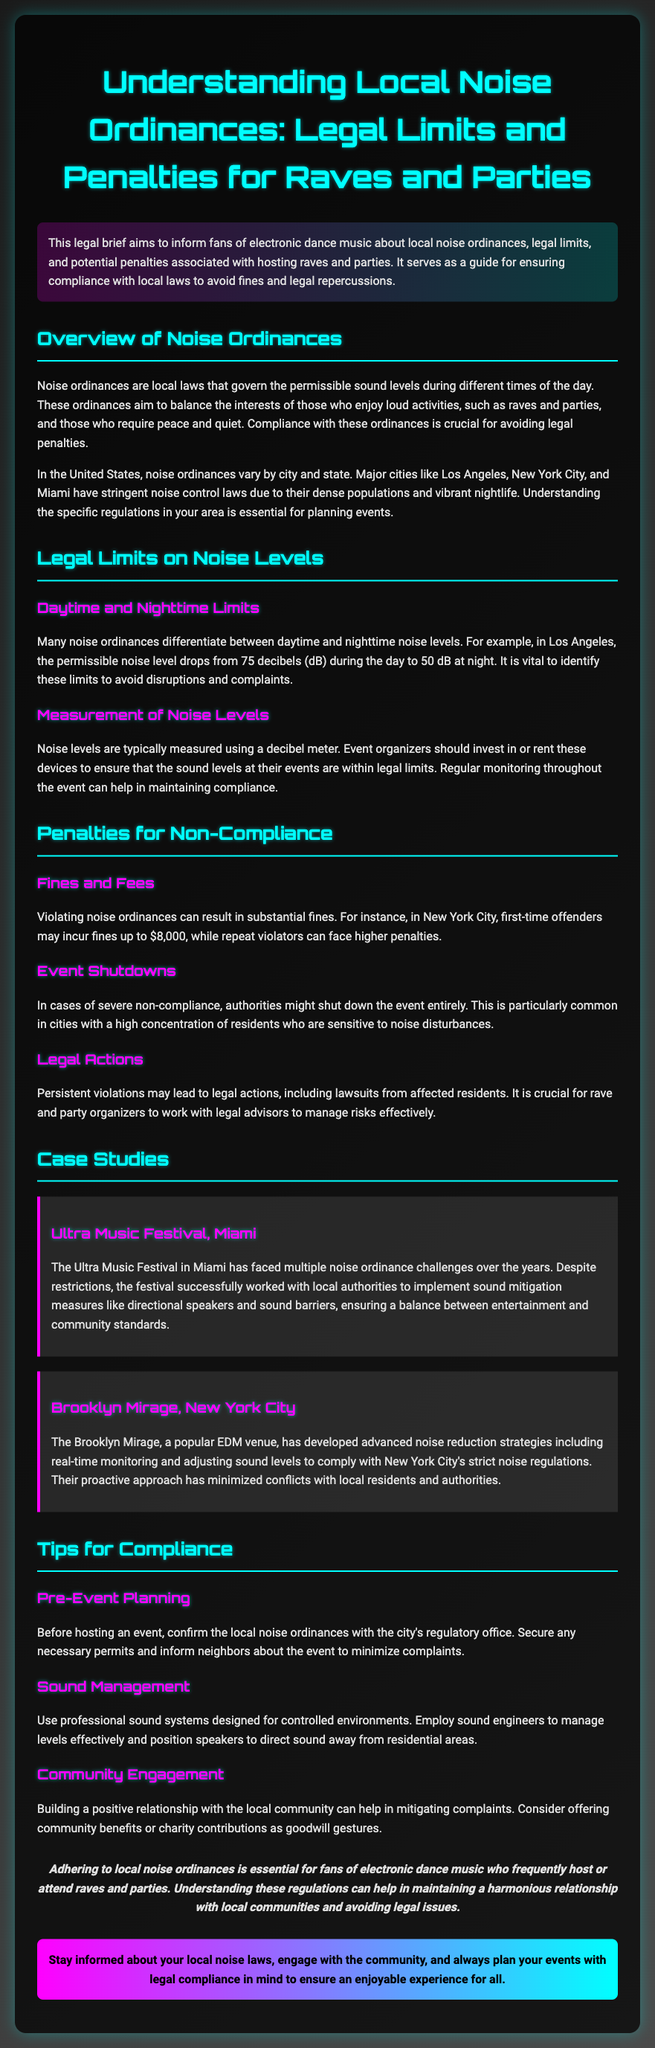what is the maximum permissible noise level in Los Angeles during the day? The document provides a specific noise limit for Los Angeles, which is 75 decibels during the day.
Answer: 75 decibels what is the maximum permissible noise level in Los Angeles at night? The legal brief mentions that the permissible noise level in Los Angeles drops to 50 decibels at night.
Answer: 50 decibels what is the fine for first-time offenders in New York City? According to the document, first-time offenders in New York City may incur fines up to $8,000.
Answer: $8,000 what are two sound management strategies recommended for event organizers? The document advises using professional sound systems and employing sound engineers as sound management strategies.
Answer: Professional sound systems and sound engineers which festival faced multiple noise ordinance challenges in Miami? The Ultra Music Festival is specifically named in the document as having faced noise ordinance challenges.
Answer: Ultra Music Festival what is a key tip for pre-event planning mentioned in the document? The legal brief highlights the importance of confirming local noise ordinances with the city’s regulatory office as a key tip for pre-event planning.
Answer: Confirm local noise ordinances what could happen in cases of severe non-compliance with noise ordinances? The brief states that authorities might shut down the event entirely in cases of severe non-compliance.
Answer: Event shutdowns what is a proactive approach taken by the Brooklyn Mirage to comply with noise regulations? The document describes the Brooklyn Mirage's use of real-time monitoring and adjusting sound levels to comply with noise regulations as a proactive approach.
Answer: Real-time monitoring what main goal do noise ordinances serve? The legal brief explains that noise ordinances aim to balance the interests of those who enjoy loud activities with those who require peace and quiet.
Answer: Balance interests 